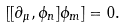<formula> <loc_0><loc_0><loc_500><loc_500>[ [ \partial _ { \mu } , \phi _ { n } ] \phi _ { m } ] = 0 .</formula> 